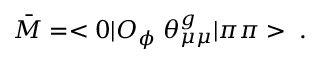<formula> <loc_0><loc_0><loc_500><loc_500>\bar { M } = < 0 | O _ { \phi } \, \theta _ { \mu \mu } ^ { g } | \pi \pi > \, .</formula> 